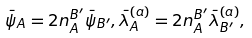Convert formula to latex. <formula><loc_0><loc_0><loc_500><loc_500>\bar { \psi } _ { A } = 2 n _ { A } ^ { B ^ { \prime } } \bar { \psi } _ { B ^ { \prime } } , \bar { \lambda } ^ { ( a ) } _ { A } = 2 n _ { A } ^ { B ^ { \prime } } \bar { \lambda } ^ { ( a ) } _ { B ^ { \prime } } ,</formula> 